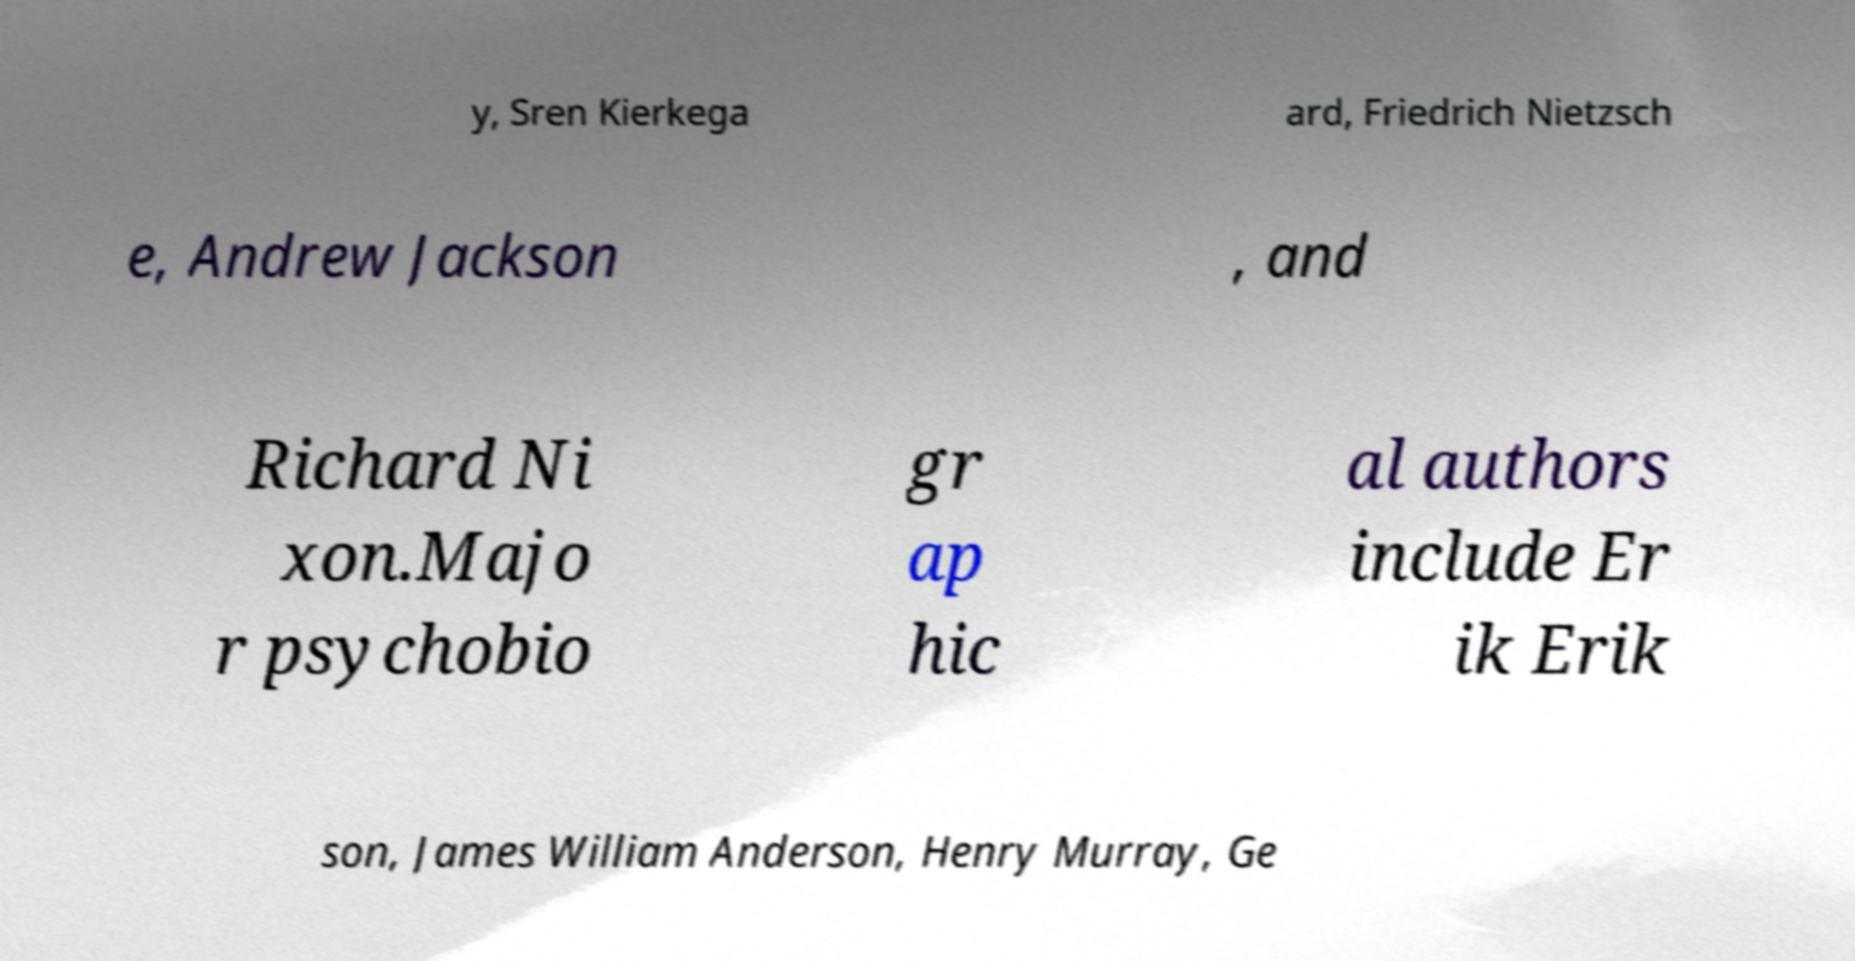Can you accurately transcribe the text from the provided image for me? y, Sren Kierkega ard, Friedrich Nietzsch e, Andrew Jackson , and Richard Ni xon.Majo r psychobio gr ap hic al authors include Er ik Erik son, James William Anderson, Henry Murray, Ge 